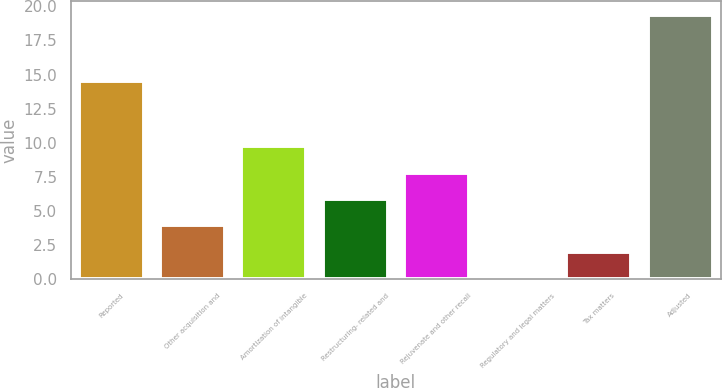Convert chart. <chart><loc_0><loc_0><loc_500><loc_500><bar_chart><fcel>Reported<fcel>Other acquisition and<fcel>Amortization of intangible<fcel>Restructuring- related and<fcel>Rejuvenate and other recall<fcel>Regulatory and legal matters<fcel>Tax matters<fcel>Adjusted<nl><fcel>14.5<fcel>3.96<fcel>9.75<fcel>5.89<fcel>7.82<fcel>0.1<fcel>2.03<fcel>19.4<nl></chart> 